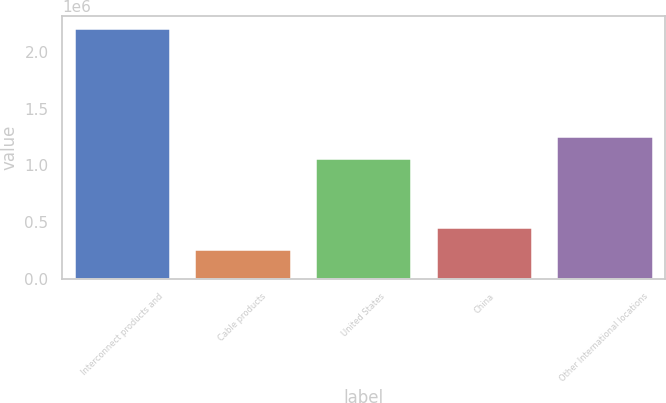<chart> <loc_0><loc_0><loc_500><loc_500><bar_chart><fcel>Interconnect products and<fcel>Cable products<fcel>United States<fcel>China<fcel>Other International locations<nl><fcel>2.20751e+06<fcel>263922<fcel>1.05997e+06<fcel>458281<fcel>1.25433e+06<nl></chart> 